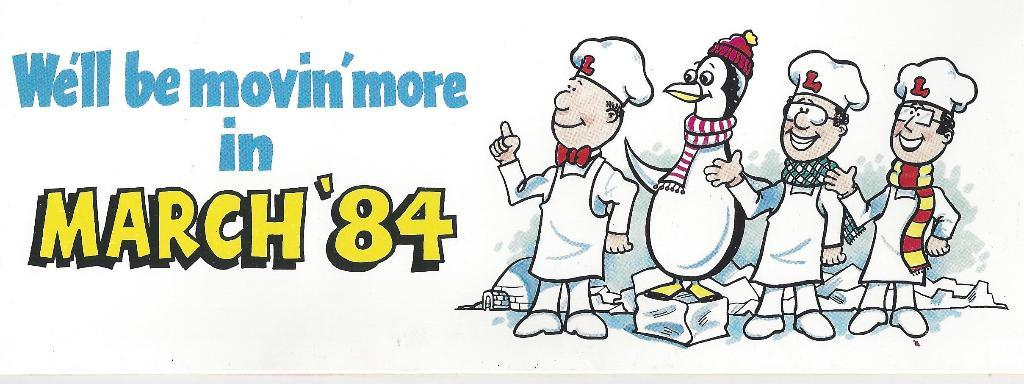What types of characters are present in the image? There are animated persons and animals in the image. What else can be found in the image besides the characters? There is text present in the image. What type of soap is being used by the animated persons in the image? There is no soap present in the image; it features animated persons and animals along with text. 